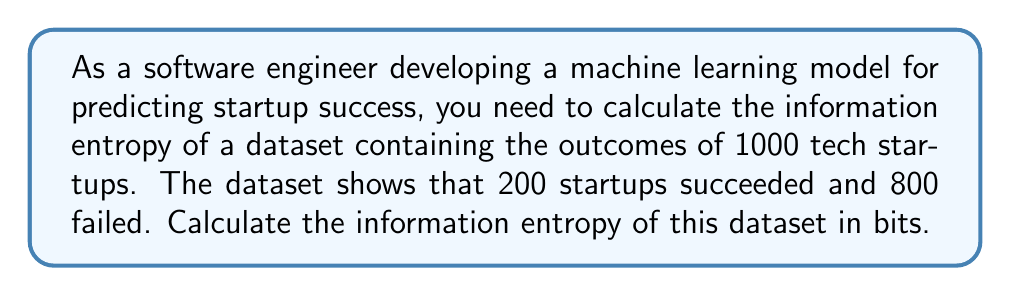What is the answer to this math problem? Let's approach this step-by-step:

1) The formula for information entropy is:

   $$H = -\sum_{i=1}^{n} p_i \log_2(p_i)$$

   where $p_i$ is the probability of each outcome.

2) In this case, we have two outcomes:
   - Success (S): p(S) = 200/1000 = 0.2
   - Failure (F): p(F) = 800/1000 = 0.8

3) Let's plug these into our entropy formula:

   $$H = -[p(S) \log_2(p(S)) + p(F) \log_2(p(F))]$$

4) Substituting the values:

   $$H = -[0.2 \log_2(0.2) + 0.8 \log_2(0.8)]$$

5) Now, let's calculate each logarithm:
   
   $\log_2(0.2) \approx -2.3219$
   $\log_2(0.8) \approx -0.3219$

6) Multiplying:

   $0.2 \times (-2.3219) \approx -0.4644$
   $0.8 \times (-0.3219) \approx -0.2575$

7) Adding these up and taking the negative:

   $$H = -(-0.4644 - 0.2575) = 0.7219$$

Therefore, the information entropy of the dataset is approximately 0.7219 bits.
Answer: 0.7219 bits 